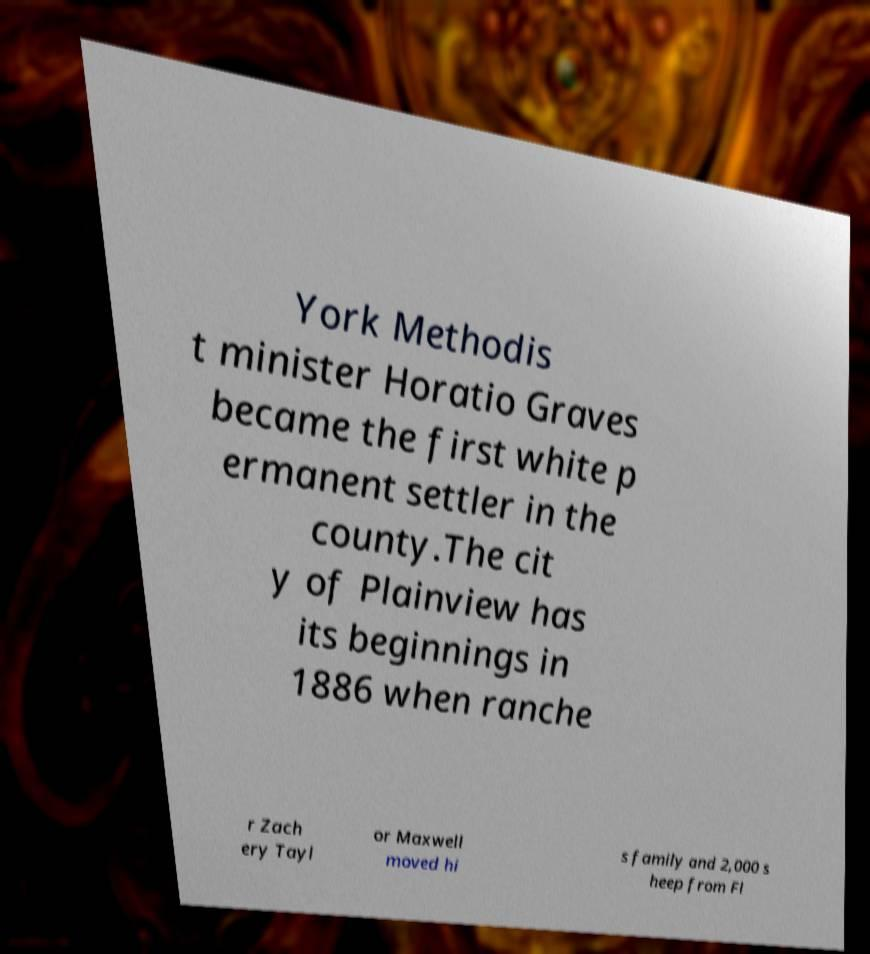I need the written content from this picture converted into text. Can you do that? York Methodis t minister Horatio Graves became the first white p ermanent settler in the county.The cit y of Plainview has its beginnings in 1886 when ranche r Zach ery Tayl or Maxwell moved hi s family and 2,000 s heep from Fl 